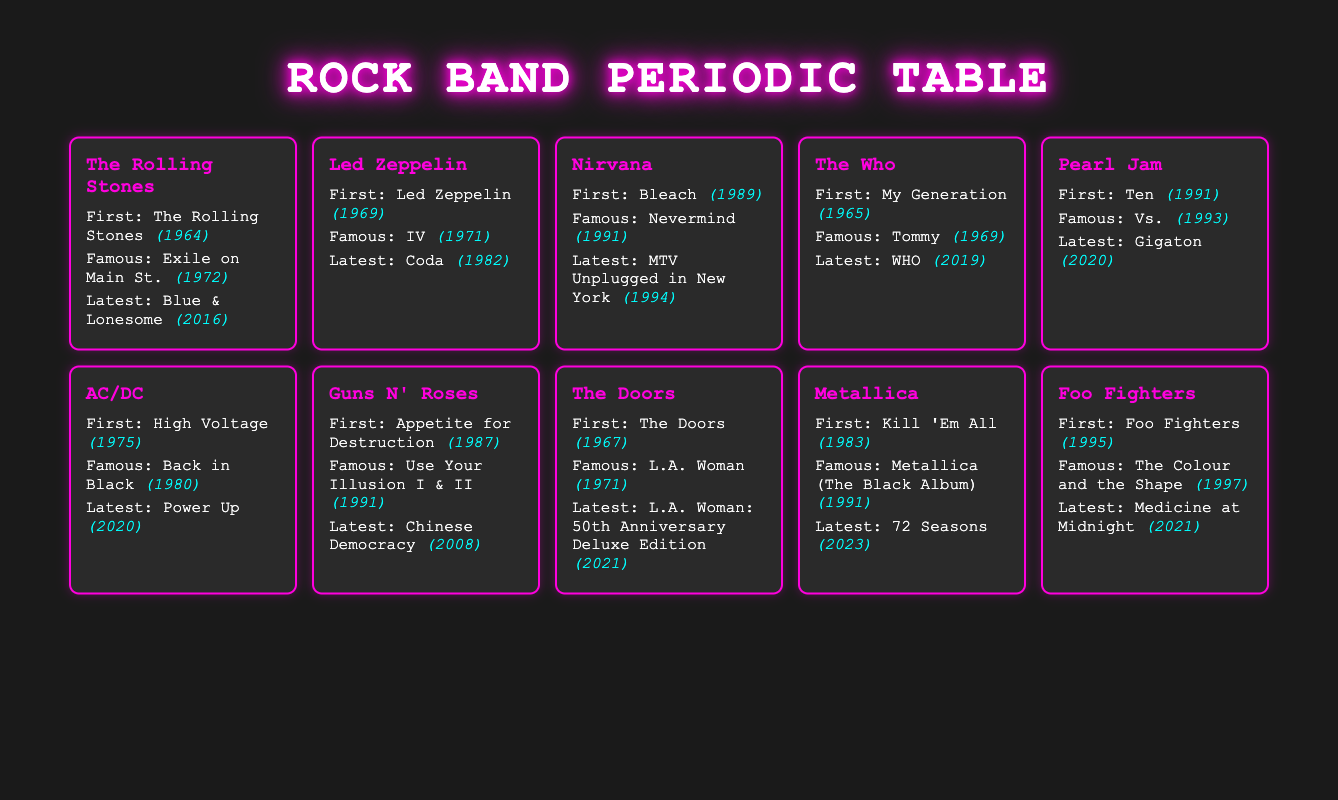What is the first album of The Who? The first album of The Who is mentioned in the table, specifically under their information. It states "My Generation" as their first album.
Answer: My Generation Which band released an album in 2016? The table includes the latest albums by each band. Looking at the latest album for each band, The Rolling Stones is listed with "Blue & Lonesome" released in 2016.
Answer: The Rolling Stones What is the year difference between the first album and the famous album of Led Zeppelin? From the table, Led Zeppelin's first album was released in 1969 and their famous album in 1971. The difference is 1971 - 1969 = 2 years.
Answer: 2 Is Nirvana's famous album older than AC/DC's famous album? The table indicates that Nirvana's famous album "Nevermind" was released in 1991 and AC/DC's famous album "Back in Black" was released in 1980. Since 1991 is after 1980, the answer is no.
Answer: No Which band's first album was released closest in time to Pearl Jam’s first album? Pearl Jam's first album "Ten" was released in 1991. Looking at the other bands, the first album released in the same year (1991) was by Nirvana, which also released in 1989; no other bands were close, but Nirvana is only 2 years after Pearl Jam.
Answer: Nirvana What is the latest album released by Metallica? The table states that Metallica’s latest album is "72 Seasons," and it was released in 2023, providing a direct answer to the query regarding Metallica's most recent album.
Answer: 72 Seasons Did The Doors release their famous album in the 20th century? The famous album of The Doors, "L.A. Woman," is listed in the table with a release year of 1971, which is within the 20th century. Therefore, the answer is yes.
Answer: Yes How many years did it take from the first album to the latest album for Foo Fighters? Foo Fighters’ first album was released in 1995 and their latest album in 2021. The calculation is 2021 - 1995 = 26 years.
Answer: 26 Which band has the latest album overall? By examining the latest albums of all bands in the table, Metallica's latest album "72 Seasons" released in 2023 is the latest compared to others.
Answer: Metallica 